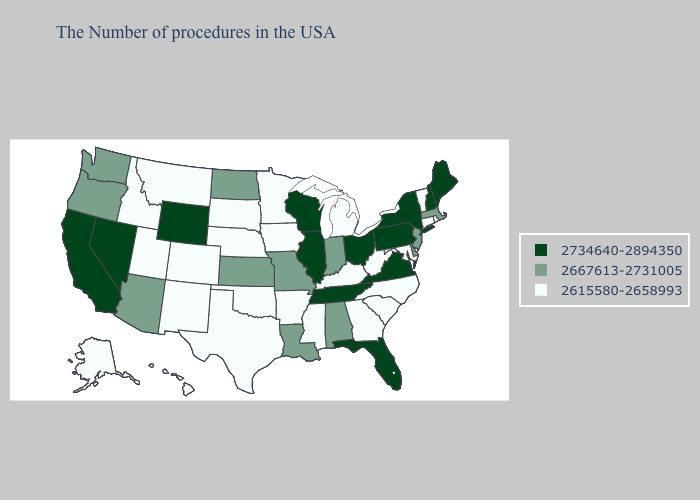Which states have the lowest value in the USA?
Write a very short answer. Rhode Island, Vermont, Connecticut, Maryland, North Carolina, South Carolina, West Virginia, Georgia, Michigan, Kentucky, Mississippi, Arkansas, Minnesota, Iowa, Nebraska, Oklahoma, Texas, South Dakota, Colorado, New Mexico, Utah, Montana, Idaho, Alaska, Hawaii. What is the lowest value in states that border Kansas?
Give a very brief answer. 2615580-2658993. Name the states that have a value in the range 2667613-2731005?
Keep it brief. Massachusetts, New Jersey, Delaware, Indiana, Alabama, Louisiana, Missouri, Kansas, North Dakota, Arizona, Washington, Oregon. Among the states that border Texas , which have the highest value?
Be succinct. Louisiana. What is the value of Indiana?
Give a very brief answer. 2667613-2731005. Does Idaho have the same value as Utah?
Quick response, please. Yes. Among the states that border Alabama , which have the lowest value?
Quick response, please. Georgia, Mississippi. What is the lowest value in the Northeast?
Give a very brief answer. 2615580-2658993. Among the states that border Texas , does Arkansas have the lowest value?
Be succinct. Yes. Name the states that have a value in the range 2667613-2731005?
Short answer required. Massachusetts, New Jersey, Delaware, Indiana, Alabama, Louisiana, Missouri, Kansas, North Dakota, Arizona, Washington, Oregon. Does the first symbol in the legend represent the smallest category?
Short answer required. No. Name the states that have a value in the range 2667613-2731005?
Quick response, please. Massachusetts, New Jersey, Delaware, Indiana, Alabama, Louisiana, Missouri, Kansas, North Dakota, Arizona, Washington, Oregon. What is the value of Missouri?
Give a very brief answer. 2667613-2731005. What is the lowest value in the West?
Give a very brief answer. 2615580-2658993. What is the lowest value in the West?
Concise answer only. 2615580-2658993. 